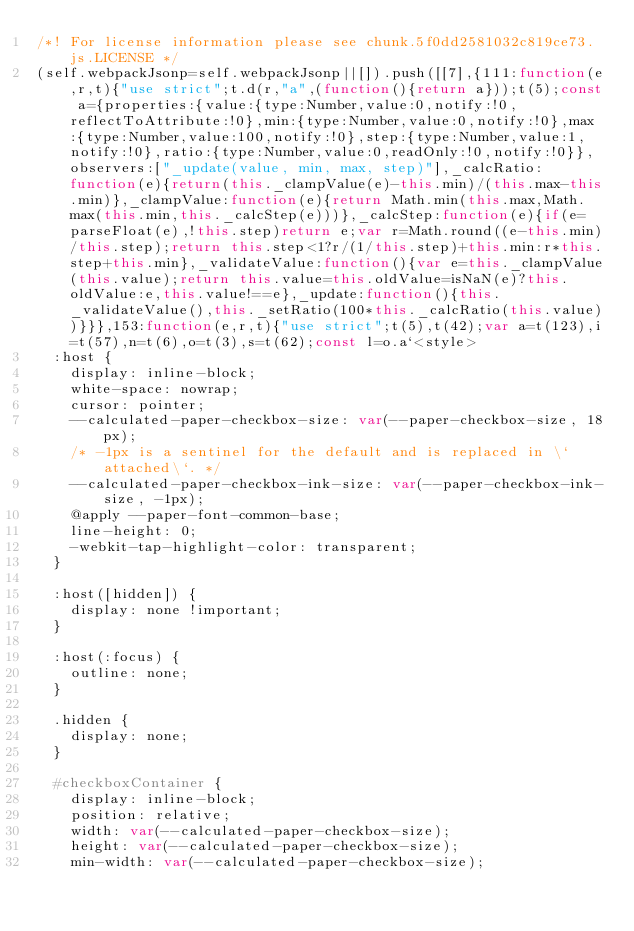Convert code to text. <code><loc_0><loc_0><loc_500><loc_500><_JavaScript_>/*! For license information please see chunk.5f0dd2581032c819ce73.js.LICENSE */
(self.webpackJsonp=self.webpackJsonp||[]).push([[7],{111:function(e,r,t){"use strict";t.d(r,"a",(function(){return a}));t(5);const a={properties:{value:{type:Number,value:0,notify:!0,reflectToAttribute:!0},min:{type:Number,value:0,notify:!0},max:{type:Number,value:100,notify:!0},step:{type:Number,value:1,notify:!0},ratio:{type:Number,value:0,readOnly:!0,notify:!0}},observers:["_update(value, min, max, step)"],_calcRatio:function(e){return(this._clampValue(e)-this.min)/(this.max-this.min)},_clampValue:function(e){return Math.min(this.max,Math.max(this.min,this._calcStep(e)))},_calcStep:function(e){if(e=parseFloat(e),!this.step)return e;var r=Math.round((e-this.min)/this.step);return this.step<1?r/(1/this.step)+this.min:r*this.step+this.min},_validateValue:function(){var e=this._clampValue(this.value);return this.value=this.oldValue=isNaN(e)?this.oldValue:e,this.value!==e},_update:function(){this._validateValue(),this._setRatio(100*this._calcRatio(this.value))}}},153:function(e,r,t){"use strict";t(5),t(42);var a=t(123),i=t(57),n=t(6),o=t(3),s=t(62);const l=o.a`<style>
  :host {
    display: inline-block;
    white-space: nowrap;
    cursor: pointer;
    --calculated-paper-checkbox-size: var(--paper-checkbox-size, 18px);
    /* -1px is a sentinel for the default and is replaced in \`attached\`. */
    --calculated-paper-checkbox-ink-size: var(--paper-checkbox-ink-size, -1px);
    @apply --paper-font-common-base;
    line-height: 0;
    -webkit-tap-highlight-color: transparent;
  }

  :host([hidden]) {
    display: none !important;
  }

  :host(:focus) {
    outline: none;
  }

  .hidden {
    display: none;
  }

  #checkboxContainer {
    display: inline-block;
    position: relative;
    width: var(--calculated-paper-checkbox-size);
    height: var(--calculated-paper-checkbox-size);
    min-width: var(--calculated-paper-checkbox-size);</code> 